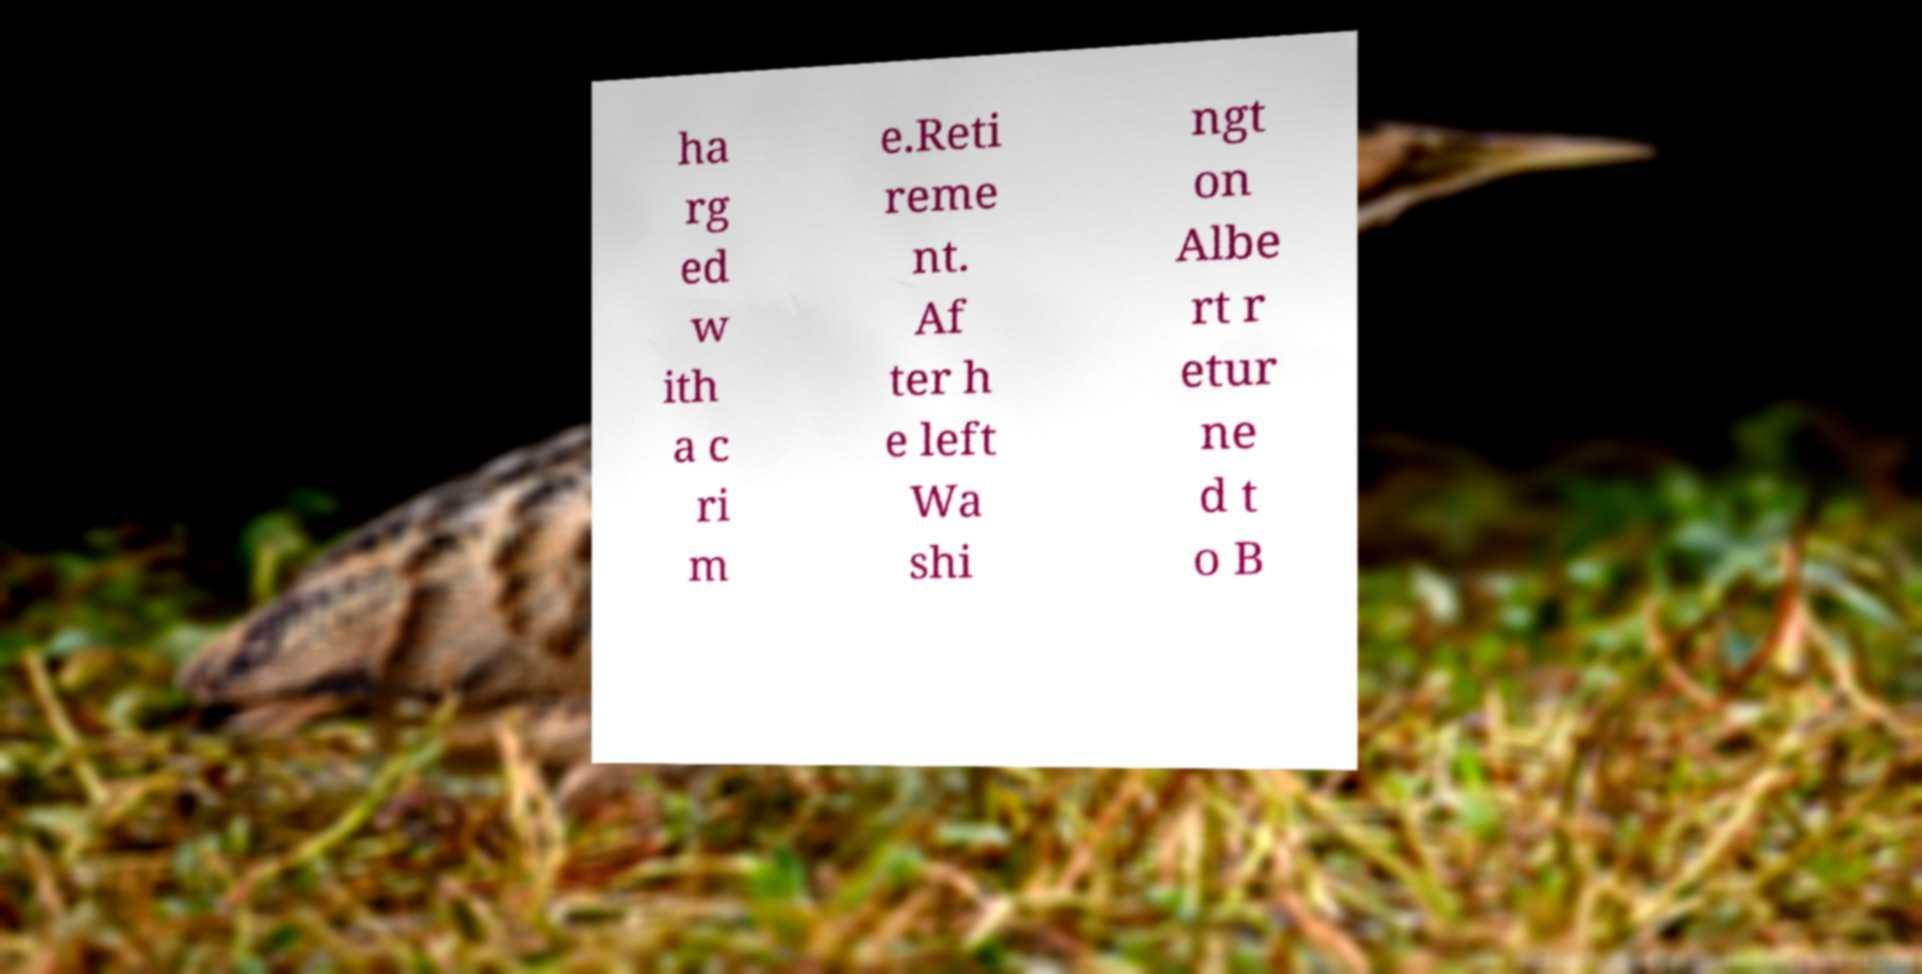Please read and relay the text visible in this image. What does it say? ha rg ed w ith a c ri m e.Reti reme nt. Af ter h e left Wa shi ngt on Albe rt r etur ne d t o B 